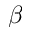<formula> <loc_0><loc_0><loc_500><loc_500>\beta</formula> 